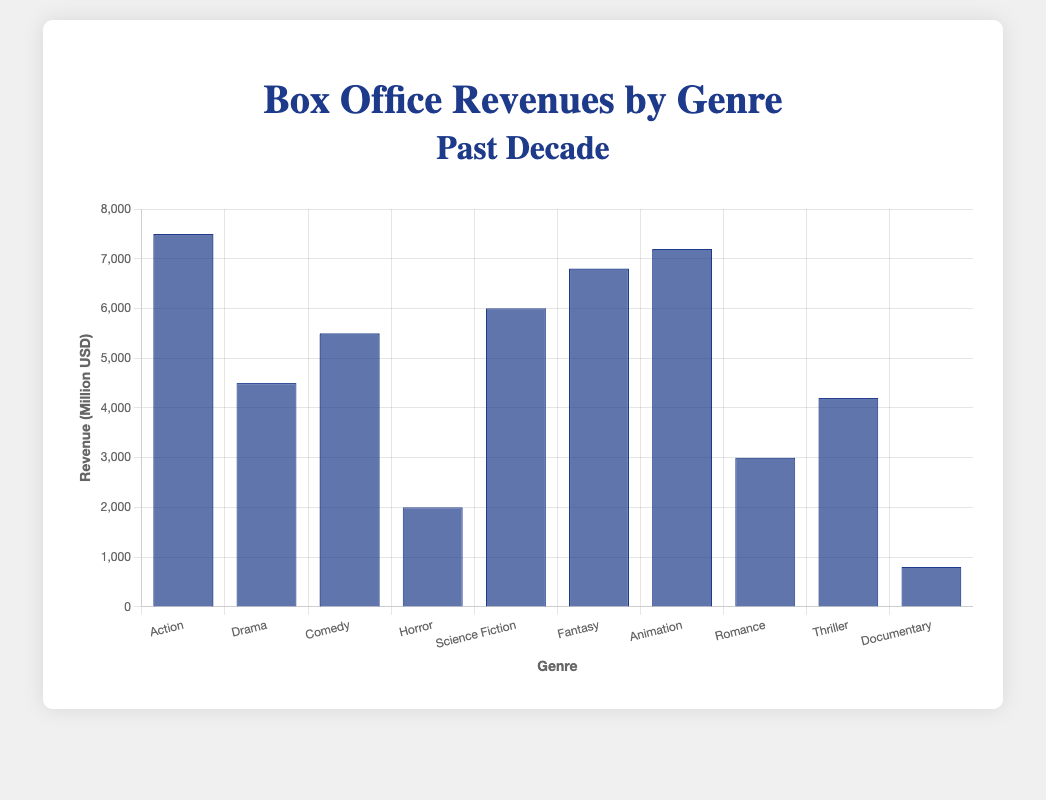Which genre generated the highest box office revenue in the past decade? The highest bar in the chart represents "Action" with a revenue of 7500 Million USD.
Answer: Action What is the difference in revenue between the genres with the highest and lowest revenues? The highest revenue is for "Action" (7500 Million USD) and the lowest is for "Documentary" (800 Million USD). The difference is 7500 - 800 = 6700 Million USD.
Answer: 6700 Million USD How much more revenue did Animation generate compared to Drama? Animation's revenue is 7200 Million USD and Drama's revenue is 4500 Million USD. The difference is 7200 - 4500 = 2700 Million USD.
Answer: 2700 Million USD Of the genres Horror and Thriller, which one had higher box office revenue? The revenue for Horror is 2000 Million USD while Thriller's revenue is 4200 Million USD. Since 4200 is greater than 2000, Thriller had higher revenue.
Answer: Thriller What is the total box office revenue generated by Science Fiction and Fantasy combined? Science Fiction generated 6000 Million USD and Fantasy generated 6800 Million USD. Their combined revenue is 6000 + 6800 = 12800 Million USD.
Answer: 12800 Million USD Order the genres by their revenues in ascending order. The revenues in ascending order are: Documentary (800), Horror (2000), Romance (3000), Thriller (4200), Drama (4500), Comedy (5500), Science Fiction (6000), Fantasy (6800), Animation (7200), Action (7500).
Answer: Documentary, Horror, Romance, Thriller, Drama, Comedy, Science Fiction, Fantasy, Animation, Action What is the average revenue of the top three genres? The top three genres are Action (7500), Animation (7200), and Fantasy (6800). Their total revenue is 7500 + 7200 + 6800 = 21500 Million USD. The average is 21500 / 3 = 7166.67 Million USD.
Answer: 7166.67 Million USD Which genre falls in the middle in terms of box office revenue? Ordering the genres by revenue: Documentary (800), Horror (2000), Romance (3000), Thriller (4200), Drama (4500), Comedy (5500), Science Fiction (6000), Fantasy (6800), Animation (7200), Action (7500). The middle one is Comedy (5500).
Answer: Comedy How does the revenue for Comedy compare to Science Fiction? Comedy's revenue is 5500 Million USD and Science Fiction's revenue is 6000 Million USD. Since 5500 is less than 6000, Comedy generated less revenue than Science Fiction.
Answer: Less What's the total revenue generated by genres with revenues below 5000 Million USD? The genres below 5000 Million USD are Documentary (800), Horror (2000), Romance (3000), Thriller (4200), Drama (4500). Their total revenue is 800 + 2000 + 3000 + 4200 + 4500 = 14500 Million USD.
Answer: 14500 Million USD 